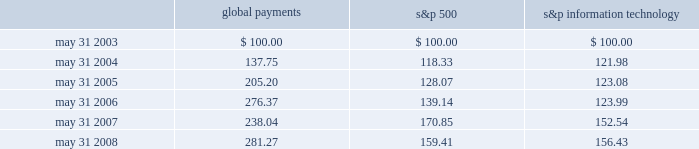Stock performance graph the following line-graph presentation compares our cumulative shareholder returns with the standard & poor 2019s information technology index and the standard & poor 2019s 500 stock index for the past five years .
The line graph assumes the investment of $ 100 in our common stock , the standard & poor 2019s information technology index , and the standard & poor 2019s 500 stock index on may 31 , 2003 and assumes reinvestment of all dividends .
Comparison of 5 year cumulative total return* among global payments inc. , the s&p 500 index and the s&p information technology index 5/03 5/04 5/05 5/06 5/07 5/08 global payments inc .
S&p 500 s&p information technology * $ 100 invested on 5/31/03 in stock or index-including reinvestment of dividends .
Fiscal year ending may 31 .
Global payments s&p 500 information technology .
Issuer purchases of equity securities in fiscal 2007 , our board of directors approved a share repurchase program that authorized the purchase of up to $ 100 million of global payments 2019 stock in the open market or as otherwise may be determined by us , subject to market conditions , business opportunities , and other factors .
Under this authorization , we have repurchased 2.3 million shares of our common stock .
This authorization has no expiration date and may be suspended or terminated at any time .
Repurchased shares will be retired but will be available for future issuance. .
What is the roi of global payments from 2004 to 2005? 
Computations: ((205.20 - 137.75) / 137.75)
Answer: 0.48966. 